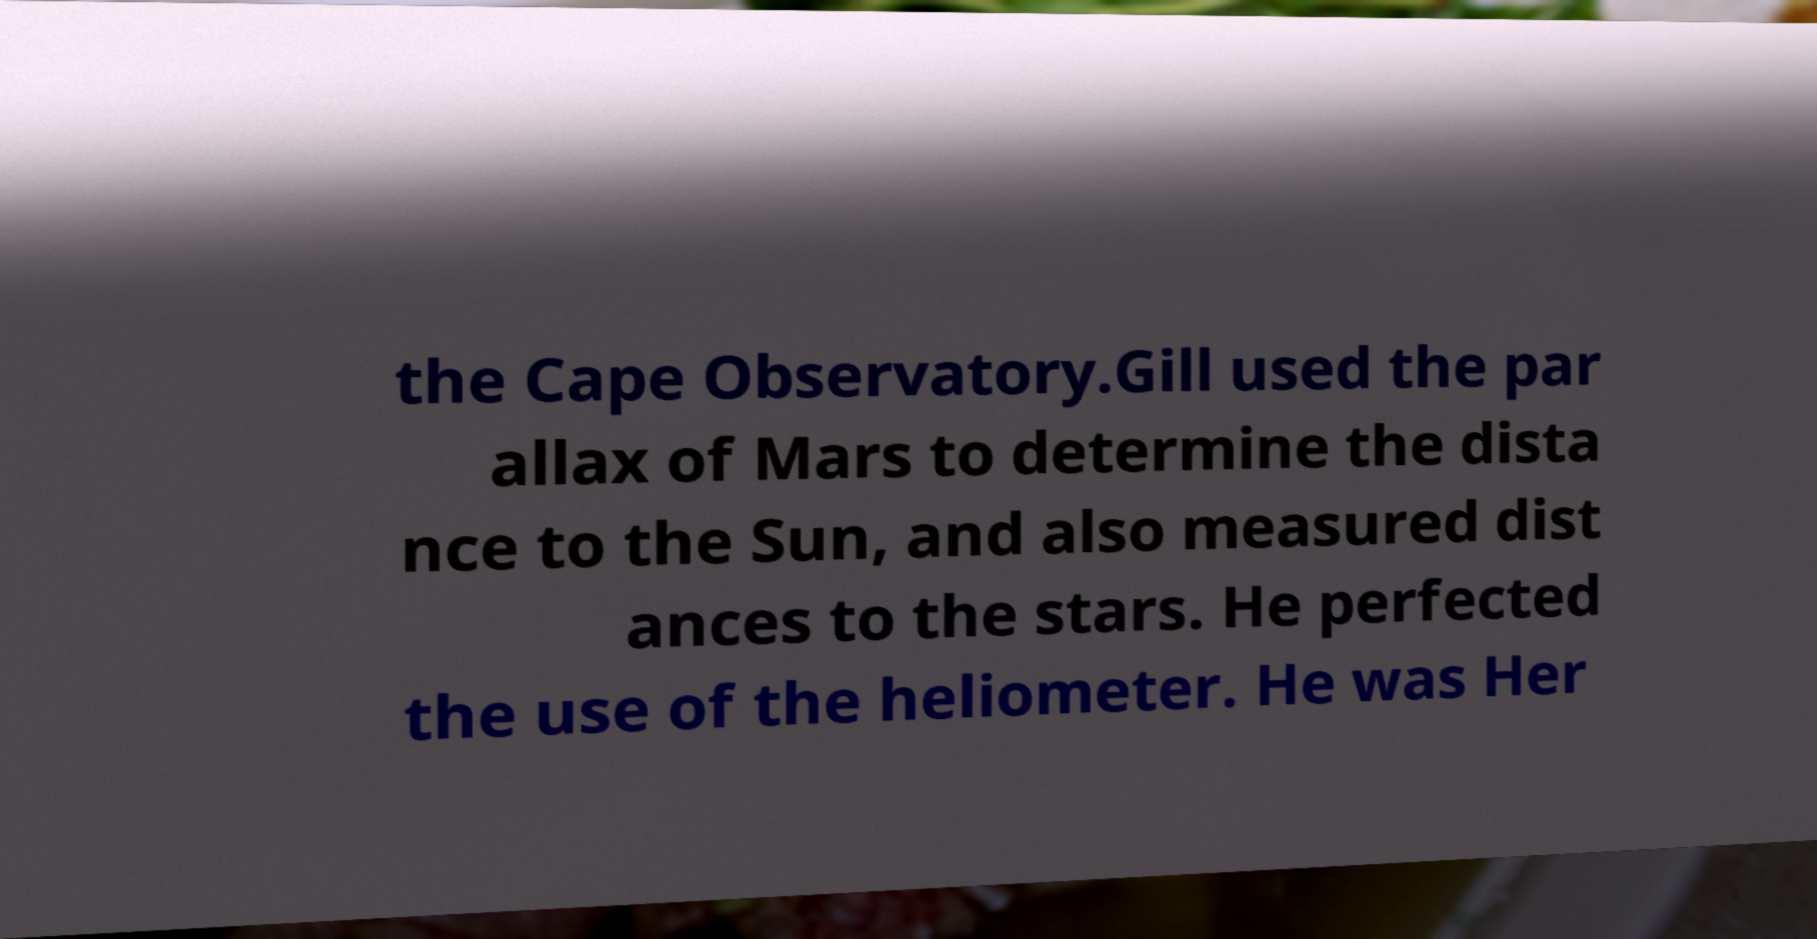What messages or text are displayed in this image? I need them in a readable, typed format. the Cape Observatory.Gill used the par allax of Mars to determine the dista nce to the Sun, and also measured dist ances to the stars. He perfected the use of the heliometer. He was Her 